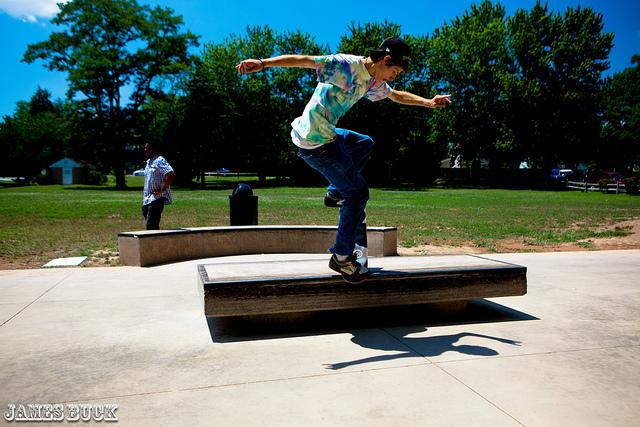In which space is this person boarding? Please explain your reasoning. park. The image contains grass, trees, benches, and a walkway. the buildings are not consistent with an urban development, and the climate appears moderate. 